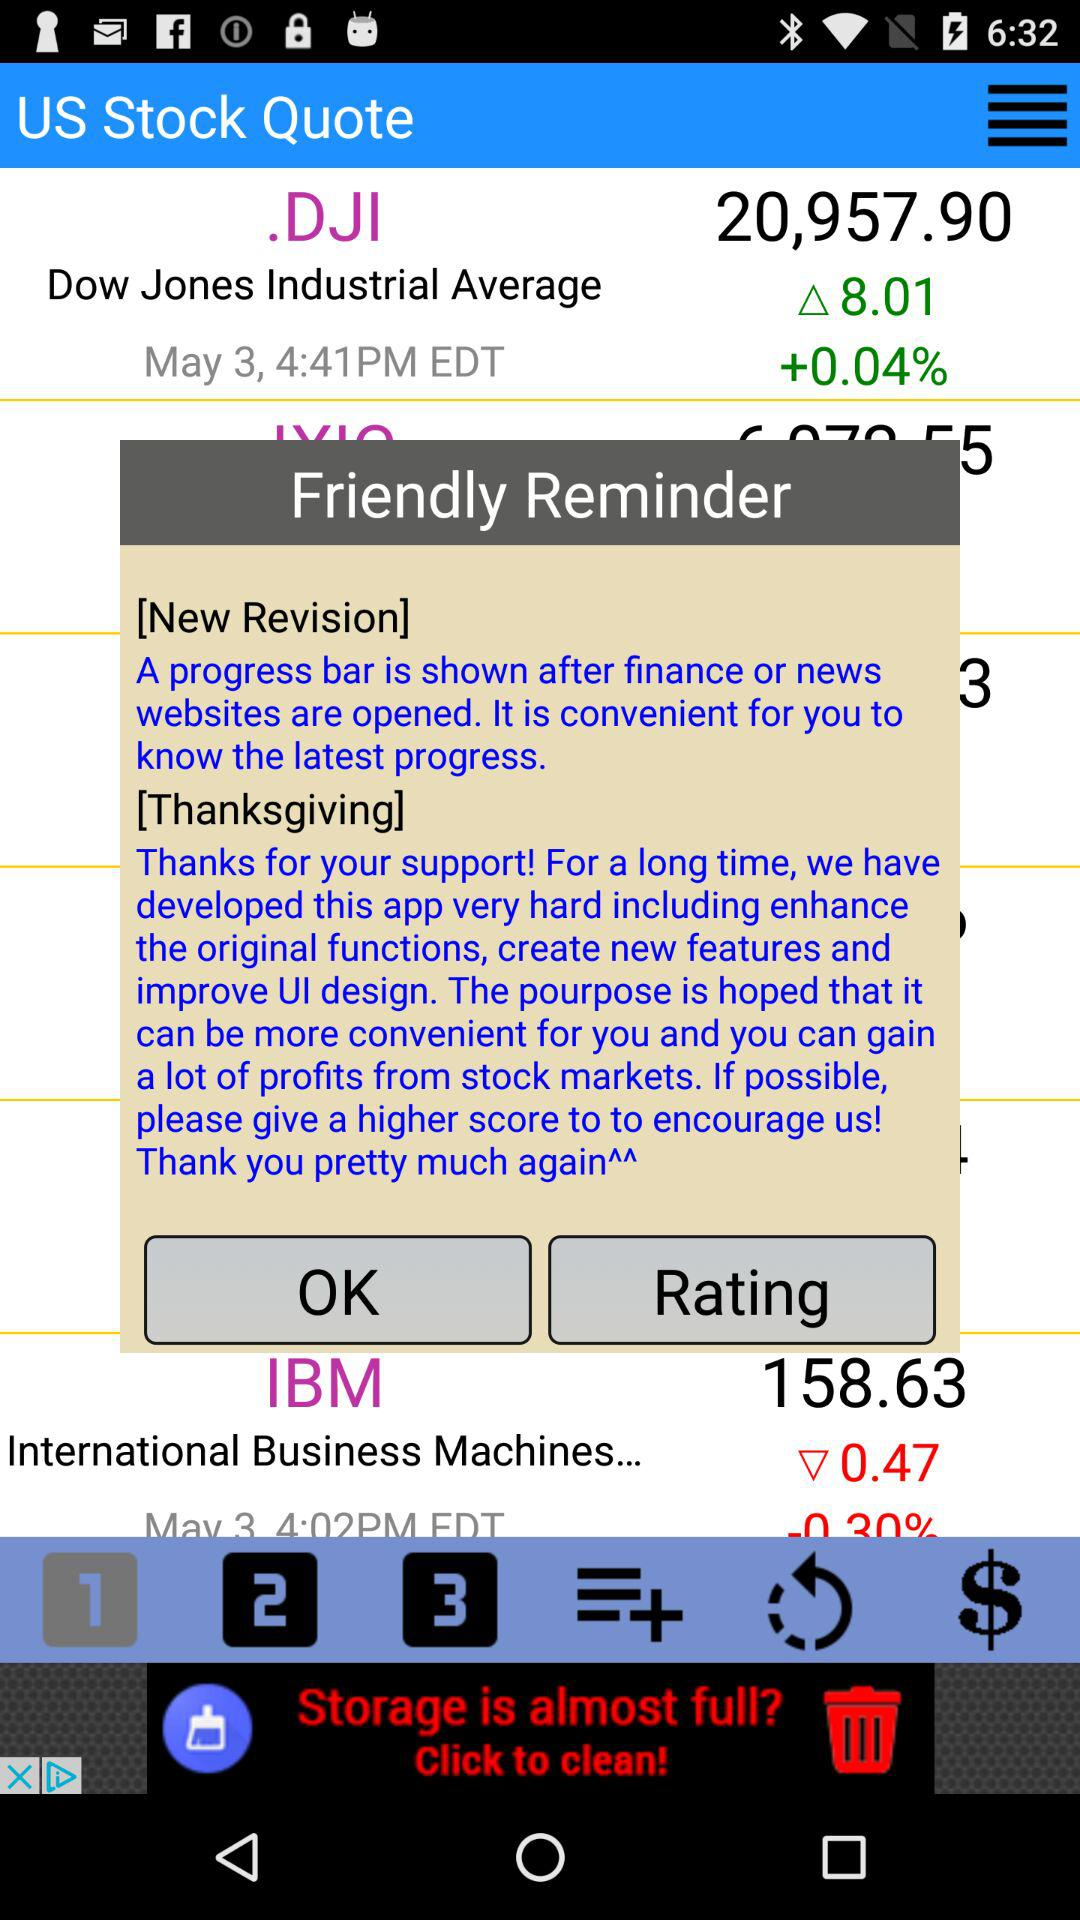What is the stock price of IBM? The stock price of IBM is 158.63. 